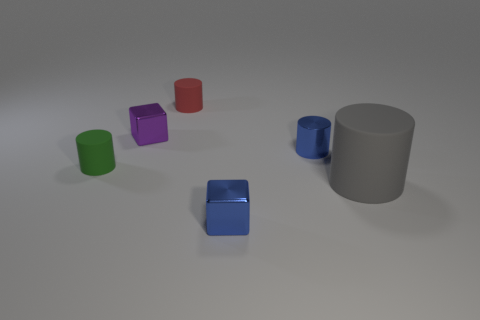Add 2 small gray rubber objects. How many objects exist? 8 Subtract all cylinders. How many objects are left? 2 Add 1 tiny green rubber cylinders. How many tiny green rubber cylinders are left? 2 Add 5 small metal cylinders. How many small metal cylinders exist? 6 Subtract 0 green blocks. How many objects are left? 6 Subtract all small rubber objects. Subtract all green rubber objects. How many objects are left? 3 